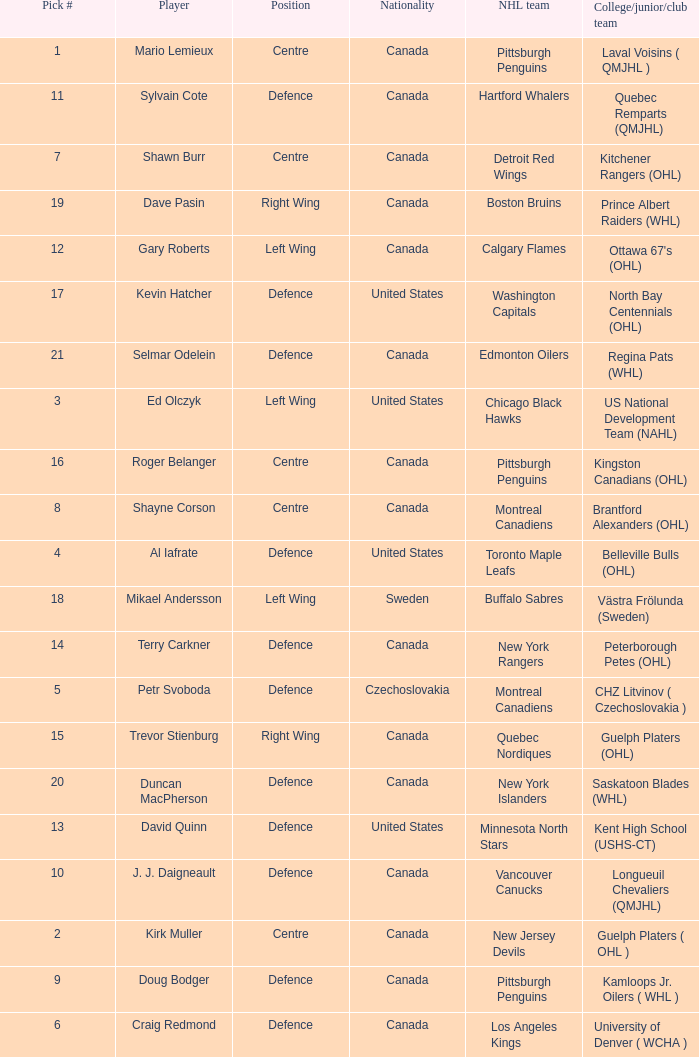What daft pick number is the player coming from Regina Pats (WHL)? 21.0. 